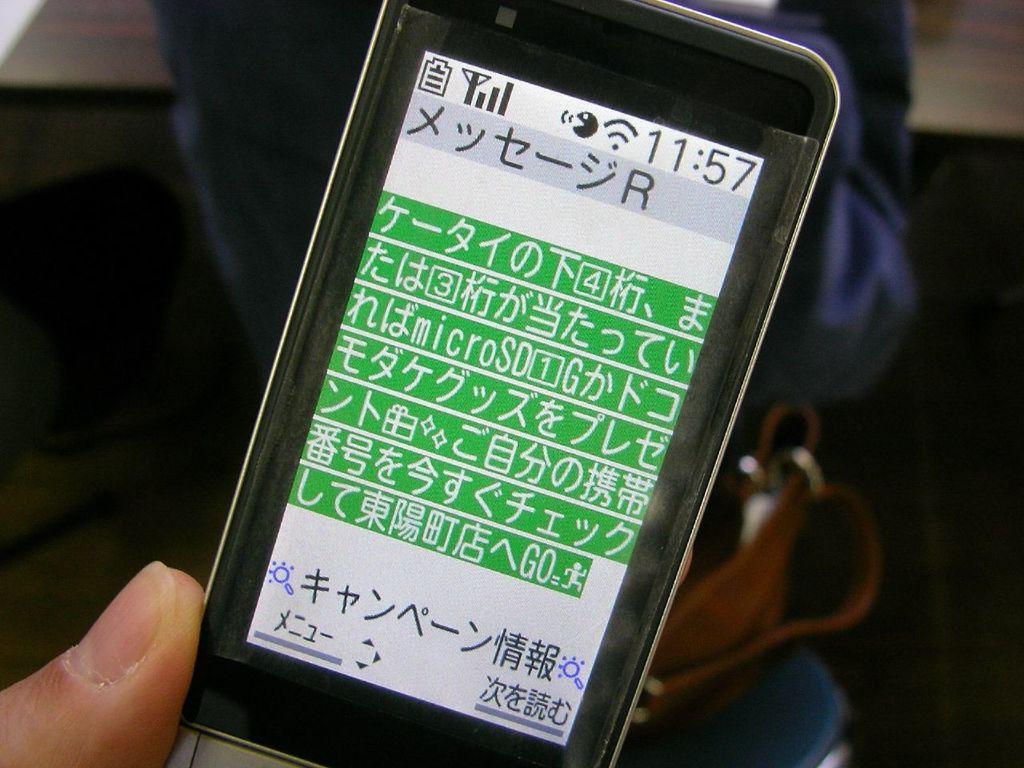In one or two sentences, can you explain what this image depicts? In this picture I can see the person's hand who is holding a mobile phone. In the back I can see another person who is standing near to the table. 